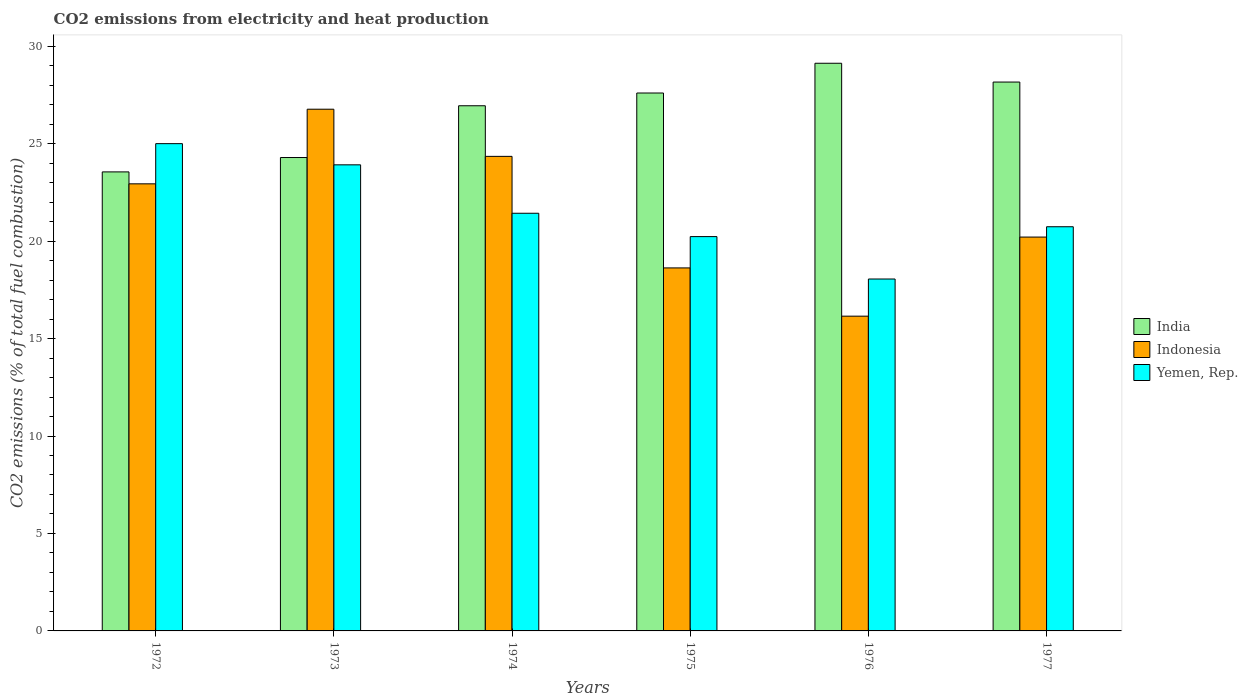How many groups of bars are there?
Your answer should be very brief. 6. Are the number of bars per tick equal to the number of legend labels?
Offer a very short reply. Yes. Are the number of bars on each tick of the X-axis equal?
Make the answer very short. Yes. How many bars are there on the 1st tick from the left?
Make the answer very short. 3. What is the label of the 4th group of bars from the left?
Ensure brevity in your answer.  1975. What is the amount of CO2 emitted in Yemen, Rep. in 1977?
Keep it short and to the point. 20.74. Across all years, what is the maximum amount of CO2 emitted in India?
Offer a very short reply. 29.12. Across all years, what is the minimum amount of CO2 emitted in Yemen, Rep.?
Give a very brief answer. 18.06. In which year was the amount of CO2 emitted in Indonesia maximum?
Make the answer very short. 1973. In which year was the amount of CO2 emitted in Yemen, Rep. minimum?
Make the answer very short. 1976. What is the total amount of CO2 emitted in India in the graph?
Provide a succinct answer. 159.67. What is the difference between the amount of CO2 emitted in Indonesia in 1976 and that in 1977?
Offer a very short reply. -4.06. What is the difference between the amount of CO2 emitted in Yemen, Rep. in 1975 and the amount of CO2 emitted in Indonesia in 1977?
Your response must be concise. 0.02. What is the average amount of CO2 emitted in Indonesia per year?
Provide a short and direct response. 21.51. In the year 1975, what is the difference between the amount of CO2 emitted in Yemen, Rep. and amount of CO2 emitted in India?
Offer a terse response. -7.37. What is the ratio of the amount of CO2 emitted in Yemen, Rep. in 1973 to that in 1977?
Offer a very short reply. 1.15. Is the amount of CO2 emitted in Yemen, Rep. in 1973 less than that in 1976?
Keep it short and to the point. No. Is the difference between the amount of CO2 emitted in Yemen, Rep. in 1975 and 1977 greater than the difference between the amount of CO2 emitted in India in 1975 and 1977?
Ensure brevity in your answer.  Yes. What is the difference between the highest and the second highest amount of CO2 emitted in Indonesia?
Offer a very short reply. 2.42. What is the difference between the highest and the lowest amount of CO2 emitted in Indonesia?
Give a very brief answer. 10.62. In how many years, is the amount of CO2 emitted in Indonesia greater than the average amount of CO2 emitted in Indonesia taken over all years?
Your answer should be very brief. 3. Is the sum of the amount of CO2 emitted in India in 1972 and 1976 greater than the maximum amount of CO2 emitted in Indonesia across all years?
Make the answer very short. Yes. What does the 3rd bar from the left in 1976 represents?
Your response must be concise. Yemen, Rep. How many years are there in the graph?
Offer a terse response. 6. What is the difference between two consecutive major ticks on the Y-axis?
Your answer should be compact. 5. Are the values on the major ticks of Y-axis written in scientific E-notation?
Provide a short and direct response. No. Does the graph contain any zero values?
Provide a succinct answer. No. Does the graph contain grids?
Provide a succinct answer. No. How are the legend labels stacked?
Offer a very short reply. Vertical. What is the title of the graph?
Give a very brief answer. CO2 emissions from electricity and heat production. What is the label or title of the Y-axis?
Provide a short and direct response. CO2 emissions (% of total fuel combustion). What is the CO2 emissions (% of total fuel combustion) of India in 1972?
Provide a short and direct response. 23.55. What is the CO2 emissions (% of total fuel combustion) in Indonesia in 1972?
Keep it short and to the point. 22.94. What is the CO2 emissions (% of total fuel combustion) in Yemen, Rep. in 1972?
Ensure brevity in your answer.  25. What is the CO2 emissions (% of total fuel combustion) in India in 1973?
Ensure brevity in your answer.  24.29. What is the CO2 emissions (% of total fuel combustion) of Indonesia in 1973?
Your answer should be very brief. 26.77. What is the CO2 emissions (% of total fuel combustion) in Yemen, Rep. in 1973?
Give a very brief answer. 23.91. What is the CO2 emissions (% of total fuel combustion) in India in 1974?
Offer a very short reply. 26.94. What is the CO2 emissions (% of total fuel combustion) of Indonesia in 1974?
Offer a very short reply. 24.35. What is the CO2 emissions (% of total fuel combustion) in Yemen, Rep. in 1974?
Offer a very short reply. 21.43. What is the CO2 emissions (% of total fuel combustion) in India in 1975?
Make the answer very short. 27.6. What is the CO2 emissions (% of total fuel combustion) in Indonesia in 1975?
Provide a succinct answer. 18.62. What is the CO2 emissions (% of total fuel combustion) in Yemen, Rep. in 1975?
Keep it short and to the point. 20.23. What is the CO2 emissions (% of total fuel combustion) of India in 1976?
Ensure brevity in your answer.  29.12. What is the CO2 emissions (% of total fuel combustion) of Indonesia in 1976?
Give a very brief answer. 16.15. What is the CO2 emissions (% of total fuel combustion) of Yemen, Rep. in 1976?
Your answer should be compact. 18.06. What is the CO2 emissions (% of total fuel combustion) of India in 1977?
Your answer should be very brief. 28.16. What is the CO2 emissions (% of total fuel combustion) in Indonesia in 1977?
Give a very brief answer. 20.21. What is the CO2 emissions (% of total fuel combustion) in Yemen, Rep. in 1977?
Your response must be concise. 20.74. Across all years, what is the maximum CO2 emissions (% of total fuel combustion) of India?
Offer a very short reply. 29.12. Across all years, what is the maximum CO2 emissions (% of total fuel combustion) of Indonesia?
Provide a short and direct response. 26.77. Across all years, what is the minimum CO2 emissions (% of total fuel combustion) in India?
Offer a very short reply. 23.55. Across all years, what is the minimum CO2 emissions (% of total fuel combustion) in Indonesia?
Provide a short and direct response. 16.15. Across all years, what is the minimum CO2 emissions (% of total fuel combustion) of Yemen, Rep.?
Offer a terse response. 18.06. What is the total CO2 emissions (% of total fuel combustion) in India in the graph?
Your response must be concise. 159.67. What is the total CO2 emissions (% of total fuel combustion) in Indonesia in the graph?
Ensure brevity in your answer.  129.03. What is the total CO2 emissions (% of total fuel combustion) of Yemen, Rep. in the graph?
Provide a short and direct response. 129.37. What is the difference between the CO2 emissions (% of total fuel combustion) of India in 1972 and that in 1973?
Your answer should be very brief. -0.74. What is the difference between the CO2 emissions (% of total fuel combustion) of Indonesia in 1972 and that in 1973?
Ensure brevity in your answer.  -3.83. What is the difference between the CO2 emissions (% of total fuel combustion) of Yemen, Rep. in 1972 and that in 1973?
Your answer should be compact. 1.09. What is the difference between the CO2 emissions (% of total fuel combustion) in India in 1972 and that in 1974?
Your answer should be very brief. -3.39. What is the difference between the CO2 emissions (% of total fuel combustion) of Indonesia in 1972 and that in 1974?
Ensure brevity in your answer.  -1.41. What is the difference between the CO2 emissions (% of total fuel combustion) of Yemen, Rep. in 1972 and that in 1974?
Keep it short and to the point. 3.57. What is the difference between the CO2 emissions (% of total fuel combustion) in India in 1972 and that in 1975?
Give a very brief answer. -4.05. What is the difference between the CO2 emissions (% of total fuel combustion) of Indonesia in 1972 and that in 1975?
Give a very brief answer. 4.31. What is the difference between the CO2 emissions (% of total fuel combustion) in Yemen, Rep. in 1972 and that in 1975?
Keep it short and to the point. 4.77. What is the difference between the CO2 emissions (% of total fuel combustion) in India in 1972 and that in 1976?
Offer a terse response. -5.57. What is the difference between the CO2 emissions (% of total fuel combustion) of Indonesia in 1972 and that in 1976?
Make the answer very short. 6.79. What is the difference between the CO2 emissions (% of total fuel combustion) in Yemen, Rep. in 1972 and that in 1976?
Give a very brief answer. 6.94. What is the difference between the CO2 emissions (% of total fuel combustion) in India in 1972 and that in 1977?
Provide a short and direct response. -4.61. What is the difference between the CO2 emissions (% of total fuel combustion) of Indonesia in 1972 and that in 1977?
Your answer should be compact. 2.73. What is the difference between the CO2 emissions (% of total fuel combustion) of Yemen, Rep. in 1972 and that in 1977?
Ensure brevity in your answer.  4.26. What is the difference between the CO2 emissions (% of total fuel combustion) of India in 1973 and that in 1974?
Offer a very short reply. -2.66. What is the difference between the CO2 emissions (% of total fuel combustion) in Indonesia in 1973 and that in 1974?
Give a very brief answer. 2.42. What is the difference between the CO2 emissions (% of total fuel combustion) of Yemen, Rep. in 1973 and that in 1974?
Your answer should be compact. 2.48. What is the difference between the CO2 emissions (% of total fuel combustion) in India in 1973 and that in 1975?
Ensure brevity in your answer.  -3.31. What is the difference between the CO2 emissions (% of total fuel combustion) of Indonesia in 1973 and that in 1975?
Provide a short and direct response. 8.14. What is the difference between the CO2 emissions (% of total fuel combustion) in Yemen, Rep. in 1973 and that in 1975?
Keep it short and to the point. 3.68. What is the difference between the CO2 emissions (% of total fuel combustion) of India in 1973 and that in 1976?
Give a very brief answer. -4.84. What is the difference between the CO2 emissions (% of total fuel combustion) of Indonesia in 1973 and that in 1976?
Make the answer very short. 10.62. What is the difference between the CO2 emissions (% of total fuel combustion) in Yemen, Rep. in 1973 and that in 1976?
Your answer should be compact. 5.86. What is the difference between the CO2 emissions (% of total fuel combustion) in India in 1973 and that in 1977?
Offer a very short reply. -3.87. What is the difference between the CO2 emissions (% of total fuel combustion) in Indonesia in 1973 and that in 1977?
Make the answer very short. 6.56. What is the difference between the CO2 emissions (% of total fuel combustion) of Yemen, Rep. in 1973 and that in 1977?
Provide a succinct answer. 3.18. What is the difference between the CO2 emissions (% of total fuel combustion) of India in 1974 and that in 1975?
Keep it short and to the point. -0.65. What is the difference between the CO2 emissions (% of total fuel combustion) in Indonesia in 1974 and that in 1975?
Your answer should be compact. 5.72. What is the difference between the CO2 emissions (% of total fuel combustion) in Yemen, Rep. in 1974 and that in 1975?
Your answer should be compact. 1.2. What is the difference between the CO2 emissions (% of total fuel combustion) in India in 1974 and that in 1976?
Provide a succinct answer. -2.18. What is the difference between the CO2 emissions (% of total fuel combustion) in Indonesia in 1974 and that in 1976?
Provide a succinct answer. 8.2. What is the difference between the CO2 emissions (% of total fuel combustion) in Yemen, Rep. in 1974 and that in 1976?
Offer a terse response. 3.37. What is the difference between the CO2 emissions (% of total fuel combustion) in India in 1974 and that in 1977?
Your answer should be very brief. -1.22. What is the difference between the CO2 emissions (% of total fuel combustion) in Indonesia in 1974 and that in 1977?
Make the answer very short. 4.14. What is the difference between the CO2 emissions (% of total fuel combustion) of Yemen, Rep. in 1974 and that in 1977?
Provide a succinct answer. 0.69. What is the difference between the CO2 emissions (% of total fuel combustion) in India in 1975 and that in 1976?
Offer a terse response. -1.53. What is the difference between the CO2 emissions (% of total fuel combustion) of Indonesia in 1975 and that in 1976?
Provide a short and direct response. 2.48. What is the difference between the CO2 emissions (% of total fuel combustion) in Yemen, Rep. in 1975 and that in 1976?
Keep it short and to the point. 2.18. What is the difference between the CO2 emissions (% of total fuel combustion) of India in 1975 and that in 1977?
Ensure brevity in your answer.  -0.56. What is the difference between the CO2 emissions (% of total fuel combustion) of Indonesia in 1975 and that in 1977?
Offer a very short reply. -1.58. What is the difference between the CO2 emissions (% of total fuel combustion) of Yemen, Rep. in 1975 and that in 1977?
Provide a succinct answer. -0.51. What is the difference between the CO2 emissions (% of total fuel combustion) of India in 1976 and that in 1977?
Your answer should be compact. 0.96. What is the difference between the CO2 emissions (% of total fuel combustion) in Indonesia in 1976 and that in 1977?
Your answer should be compact. -4.06. What is the difference between the CO2 emissions (% of total fuel combustion) of Yemen, Rep. in 1976 and that in 1977?
Make the answer very short. -2.68. What is the difference between the CO2 emissions (% of total fuel combustion) of India in 1972 and the CO2 emissions (% of total fuel combustion) of Indonesia in 1973?
Provide a succinct answer. -3.22. What is the difference between the CO2 emissions (% of total fuel combustion) of India in 1972 and the CO2 emissions (% of total fuel combustion) of Yemen, Rep. in 1973?
Give a very brief answer. -0.36. What is the difference between the CO2 emissions (% of total fuel combustion) in Indonesia in 1972 and the CO2 emissions (% of total fuel combustion) in Yemen, Rep. in 1973?
Your answer should be compact. -0.97. What is the difference between the CO2 emissions (% of total fuel combustion) of India in 1972 and the CO2 emissions (% of total fuel combustion) of Indonesia in 1974?
Your answer should be very brief. -0.8. What is the difference between the CO2 emissions (% of total fuel combustion) of India in 1972 and the CO2 emissions (% of total fuel combustion) of Yemen, Rep. in 1974?
Your answer should be compact. 2.12. What is the difference between the CO2 emissions (% of total fuel combustion) of Indonesia in 1972 and the CO2 emissions (% of total fuel combustion) of Yemen, Rep. in 1974?
Give a very brief answer. 1.51. What is the difference between the CO2 emissions (% of total fuel combustion) of India in 1972 and the CO2 emissions (% of total fuel combustion) of Indonesia in 1975?
Give a very brief answer. 4.93. What is the difference between the CO2 emissions (% of total fuel combustion) of India in 1972 and the CO2 emissions (% of total fuel combustion) of Yemen, Rep. in 1975?
Offer a terse response. 3.32. What is the difference between the CO2 emissions (% of total fuel combustion) in Indonesia in 1972 and the CO2 emissions (% of total fuel combustion) in Yemen, Rep. in 1975?
Your answer should be very brief. 2.71. What is the difference between the CO2 emissions (% of total fuel combustion) of India in 1972 and the CO2 emissions (% of total fuel combustion) of Indonesia in 1976?
Your answer should be compact. 7.4. What is the difference between the CO2 emissions (% of total fuel combustion) of India in 1972 and the CO2 emissions (% of total fuel combustion) of Yemen, Rep. in 1976?
Your response must be concise. 5.5. What is the difference between the CO2 emissions (% of total fuel combustion) of Indonesia in 1972 and the CO2 emissions (% of total fuel combustion) of Yemen, Rep. in 1976?
Ensure brevity in your answer.  4.88. What is the difference between the CO2 emissions (% of total fuel combustion) in India in 1972 and the CO2 emissions (% of total fuel combustion) in Indonesia in 1977?
Your answer should be compact. 3.34. What is the difference between the CO2 emissions (% of total fuel combustion) of India in 1972 and the CO2 emissions (% of total fuel combustion) of Yemen, Rep. in 1977?
Ensure brevity in your answer.  2.81. What is the difference between the CO2 emissions (% of total fuel combustion) in Indonesia in 1972 and the CO2 emissions (% of total fuel combustion) in Yemen, Rep. in 1977?
Make the answer very short. 2.2. What is the difference between the CO2 emissions (% of total fuel combustion) of India in 1973 and the CO2 emissions (% of total fuel combustion) of Indonesia in 1974?
Your response must be concise. -0.06. What is the difference between the CO2 emissions (% of total fuel combustion) in India in 1973 and the CO2 emissions (% of total fuel combustion) in Yemen, Rep. in 1974?
Your answer should be compact. 2.86. What is the difference between the CO2 emissions (% of total fuel combustion) of Indonesia in 1973 and the CO2 emissions (% of total fuel combustion) of Yemen, Rep. in 1974?
Your answer should be compact. 5.34. What is the difference between the CO2 emissions (% of total fuel combustion) in India in 1973 and the CO2 emissions (% of total fuel combustion) in Indonesia in 1975?
Give a very brief answer. 5.66. What is the difference between the CO2 emissions (% of total fuel combustion) of India in 1973 and the CO2 emissions (% of total fuel combustion) of Yemen, Rep. in 1975?
Offer a very short reply. 4.06. What is the difference between the CO2 emissions (% of total fuel combustion) of Indonesia in 1973 and the CO2 emissions (% of total fuel combustion) of Yemen, Rep. in 1975?
Offer a very short reply. 6.54. What is the difference between the CO2 emissions (% of total fuel combustion) of India in 1973 and the CO2 emissions (% of total fuel combustion) of Indonesia in 1976?
Ensure brevity in your answer.  8.14. What is the difference between the CO2 emissions (% of total fuel combustion) of India in 1973 and the CO2 emissions (% of total fuel combustion) of Yemen, Rep. in 1976?
Ensure brevity in your answer.  6.23. What is the difference between the CO2 emissions (% of total fuel combustion) in Indonesia in 1973 and the CO2 emissions (% of total fuel combustion) in Yemen, Rep. in 1976?
Your answer should be compact. 8.71. What is the difference between the CO2 emissions (% of total fuel combustion) in India in 1973 and the CO2 emissions (% of total fuel combustion) in Indonesia in 1977?
Your answer should be very brief. 4.08. What is the difference between the CO2 emissions (% of total fuel combustion) in India in 1973 and the CO2 emissions (% of total fuel combustion) in Yemen, Rep. in 1977?
Offer a very short reply. 3.55. What is the difference between the CO2 emissions (% of total fuel combustion) of Indonesia in 1973 and the CO2 emissions (% of total fuel combustion) of Yemen, Rep. in 1977?
Keep it short and to the point. 6.03. What is the difference between the CO2 emissions (% of total fuel combustion) of India in 1974 and the CO2 emissions (% of total fuel combustion) of Indonesia in 1975?
Offer a very short reply. 8.32. What is the difference between the CO2 emissions (% of total fuel combustion) of India in 1974 and the CO2 emissions (% of total fuel combustion) of Yemen, Rep. in 1975?
Offer a very short reply. 6.71. What is the difference between the CO2 emissions (% of total fuel combustion) of Indonesia in 1974 and the CO2 emissions (% of total fuel combustion) of Yemen, Rep. in 1975?
Ensure brevity in your answer.  4.12. What is the difference between the CO2 emissions (% of total fuel combustion) in India in 1974 and the CO2 emissions (% of total fuel combustion) in Indonesia in 1976?
Provide a succinct answer. 10.8. What is the difference between the CO2 emissions (% of total fuel combustion) in India in 1974 and the CO2 emissions (% of total fuel combustion) in Yemen, Rep. in 1976?
Keep it short and to the point. 8.89. What is the difference between the CO2 emissions (% of total fuel combustion) in Indonesia in 1974 and the CO2 emissions (% of total fuel combustion) in Yemen, Rep. in 1976?
Give a very brief answer. 6.29. What is the difference between the CO2 emissions (% of total fuel combustion) in India in 1974 and the CO2 emissions (% of total fuel combustion) in Indonesia in 1977?
Give a very brief answer. 6.74. What is the difference between the CO2 emissions (% of total fuel combustion) in India in 1974 and the CO2 emissions (% of total fuel combustion) in Yemen, Rep. in 1977?
Your answer should be compact. 6.21. What is the difference between the CO2 emissions (% of total fuel combustion) in Indonesia in 1974 and the CO2 emissions (% of total fuel combustion) in Yemen, Rep. in 1977?
Offer a terse response. 3.61. What is the difference between the CO2 emissions (% of total fuel combustion) of India in 1975 and the CO2 emissions (% of total fuel combustion) of Indonesia in 1976?
Offer a terse response. 11.45. What is the difference between the CO2 emissions (% of total fuel combustion) in India in 1975 and the CO2 emissions (% of total fuel combustion) in Yemen, Rep. in 1976?
Offer a very short reply. 9.54. What is the difference between the CO2 emissions (% of total fuel combustion) of Indonesia in 1975 and the CO2 emissions (% of total fuel combustion) of Yemen, Rep. in 1976?
Your answer should be compact. 0.57. What is the difference between the CO2 emissions (% of total fuel combustion) of India in 1975 and the CO2 emissions (% of total fuel combustion) of Indonesia in 1977?
Your answer should be compact. 7.39. What is the difference between the CO2 emissions (% of total fuel combustion) in India in 1975 and the CO2 emissions (% of total fuel combustion) in Yemen, Rep. in 1977?
Your response must be concise. 6.86. What is the difference between the CO2 emissions (% of total fuel combustion) in Indonesia in 1975 and the CO2 emissions (% of total fuel combustion) in Yemen, Rep. in 1977?
Keep it short and to the point. -2.11. What is the difference between the CO2 emissions (% of total fuel combustion) in India in 1976 and the CO2 emissions (% of total fuel combustion) in Indonesia in 1977?
Offer a very short reply. 8.92. What is the difference between the CO2 emissions (% of total fuel combustion) in India in 1976 and the CO2 emissions (% of total fuel combustion) in Yemen, Rep. in 1977?
Your response must be concise. 8.39. What is the difference between the CO2 emissions (% of total fuel combustion) of Indonesia in 1976 and the CO2 emissions (% of total fuel combustion) of Yemen, Rep. in 1977?
Your response must be concise. -4.59. What is the average CO2 emissions (% of total fuel combustion) of India per year?
Give a very brief answer. 26.61. What is the average CO2 emissions (% of total fuel combustion) in Indonesia per year?
Offer a very short reply. 21.51. What is the average CO2 emissions (% of total fuel combustion) in Yemen, Rep. per year?
Offer a very short reply. 21.56. In the year 1972, what is the difference between the CO2 emissions (% of total fuel combustion) of India and CO2 emissions (% of total fuel combustion) of Indonesia?
Your answer should be very brief. 0.61. In the year 1972, what is the difference between the CO2 emissions (% of total fuel combustion) in India and CO2 emissions (% of total fuel combustion) in Yemen, Rep.?
Make the answer very short. -1.45. In the year 1972, what is the difference between the CO2 emissions (% of total fuel combustion) of Indonesia and CO2 emissions (% of total fuel combustion) of Yemen, Rep.?
Your answer should be compact. -2.06. In the year 1973, what is the difference between the CO2 emissions (% of total fuel combustion) of India and CO2 emissions (% of total fuel combustion) of Indonesia?
Keep it short and to the point. -2.48. In the year 1973, what is the difference between the CO2 emissions (% of total fuel combustion) of India and CO2 emissions (% of total fuel combustion) of Yemen, Rep.?
Provide a succinct answer. 0.38. In the year 1973, what is the difference between the CO2 emissions (% of total fuel combustion) of Indonesia and CO2 emissions (% of total fuel combustion) of Yemen, Rep.?
Offer a very short reply. 2.85. In the year 1974, what is the difference between the CO2 emissions (% of total fuel combustion) in India and CO2 emissions (% of total fuel combustion) in Indonesia?
Ensure brevity in your answer.  2.6. In the year 1974, what is the difference between the CO2 emissions (% of total fuel combustion) in India and CO2 emissions (% of total fuel combustion) in Yemen, Rep.?
Offer a terse response. 5.52. In the year 1974, what is the difference between the CO2 emissions (% of total fuel combustion) of Indonesia and CO2 emissions (% of total fuel combustion) of Yemen, Rep.?
Keep it short and to the point. 2.92. In the year 1975, what is the difference between the CO2 emissions (% of total fuel combustion) of India and CO2 emissions (% of total fuel combustion) of Indonesia?
Ensure brevity in your answer.  8.97. In the year 1975, what is the difference between the CO2 emissions (% of total fuel combustion) of India and CO2 emissions (% of total fuel combustion) of Yemen, Rep.?
Provide a short and direct response. 7.37. In the year 1975, what is the difference between the CO2 emissions (% of total fuel combustion) in Indonesia and CO2 emissions (% of total fuel combustion) in Yemen, Rep.?
Your answer should be very brief. -1.61. In the year 1976, what is the difference between the CO2 emissions (% of total fuel combustion) in India and CO2 emissions (% of total fuel combustion) in Indonesia?
Make the answer very short. 12.98. In the year 1976, what is the difference between the CO2 emissions (% of total fuel combustion) of India and CO2 emissions (% of total fuel combustion) of Yemen, Rep.?
Ensure brevity in your answer.  11.07. In the year 1976, what is the difference between the CO2 emissions (% of total fuel combustion) in Indonesia and CO2 emissions (% of total fuel combustion) in Yemen, Rep.?
Give a very brief answer. -1.91. In the year 1977, what is the difference between the CO2 emissions (% of total fuel combustion) in India and CO2 emissions (% of total fuel combustion) in Indonesia?
Your response must be concise. 7.95. In the year 1977, what is the difference between the CO2 emissions (% of total fuel combustion) in India and CO2 emissions (% of total fuel combustion) in Yemen, Rep.?
Provide a succinct answer. 7.42. In the year 1977, what is the difference between the CO2 emissions (% of total fuel combustion) in Indonesia and CO2 emissions (% of total fuel combustion) in Yemen, Rep.?
Offer a terse response. -0.53. What is the ratio of the CO2 emissions (% of total fuel combustion) in India in 1972 to that in 1973?
Offer a very short reply. 0.97. What is the ratio of the CO2 emissions (% of total fuel combustion) in Indonesia in 1972 to that in 1973?
Keep it short and to the point. 0.86. What is the ratio of the CO2 emissions (% of total fuel combustion) in Yemen, Rep. in 1972 to that in 1973?
Give a very brief answer. 1.05. What is the ratio of the CO2 emissions (% of total fuel combustion) of India in 1972 to that in 1974?
Keep it short and to the point. 0.87. What is the ratio of the CO2 emissions (% of total fuel combustion) in Indonesia in 1972 to that in 1974?
Provide a succinct answer. 0.94. What is the ratio of the CO2 emissions (% of total fuel combustion) of Yemen, Rep. in 1972 to that in 1974?
Provide a succinct answer. 1.17. What is the ratio of the CO2 emissions (% of total fuel combustion) of India in 1972 to that in 1975?
Keep it short and to the point. 0.85. What is the ratio of the CO2 emissions (% of total fuel combustion) of Indonesia in 1972 to that in 1975?
Ensure brevity in your answer.  1.23. What is the ratio of the CO2 emissions (% of total fuel combustion) in Yemen, Rep. in 1972 to that in 1975?
Your answer should be compact. 1.24. What is the ratio of the CO2 emissions (% of total fuel combustion) of India in 1972 to that in 1976?
Your answer should be very brief. 0.81. What is the ratio of the CO2 emissions (% of total fuel combustion) in Indonesia in 1972 to that in 1976?
Give a very brief answer. 1.42. What is the ratio of the CO2 emissions (% of total fuel combustion) in Yemen, Rep. in 1972 to that in 1976?
Your answer should be compact. 1.38. What is the ratio of the CO2 emissions (% of total fuel combustion) of India in 1972 to that in 1977?
Your answer should be compact. 0.84. What is the ratio of the CO2 emissions (% of total fuel combustion) in Indonesia in 1972 to that in 1977?
Ensure brevity in your answer.  1.14. What is the ratio of the CO2 emissions (% of total fuel combustion) of Yemen, Rep. in 1972 to that in 1977?
Ensure brevity in your answer.  1.21. What is the ratio of the CO2 emissions (% of total fuel combustion) in India in 1973 to that in 1974?
Offer a terse response. 0.9. What is the ratio of the CO2 emissions (% of total fuel combustion) in Indonesia in 1973 to that in 1974?
Offer a terse response. 1.1. What is the ratio of the CO2 emissions (% of total fuel combustion) of Yemen, Rep. in 1973 to that in 1974?
Your answer should be compact. 1.12. What is the ratio of the CO2 emissions (% of total fuel combustion) in India in 1973 to that in 1975?
Offer a very short reply. 0.88. What is the ratio of the CO2 emissions (% of total fuel combustion) of Indonesia in 1973 to that in 1975?
Ensure brevity in your answer.  1.44. What is the ratio of the CO2 emissions (% of total fuel combustion) of Yemen, Rep. in 1973 to that in 1975?
Offer a terse response. 1.18. What is the ratio of the CO2 emissions (% of total fuel combustion) in India in 1973 to that in 1976?
Provide a succinct answer. 0.83. What is the ratio of the CO2 emissions (% of total fuel combustion) in Indonesia in 1973 to that in 1976?
Offer a very short reply. 1.66. What is the ratio of the CO2 emissions (% of total fuel combustion) in Yemen, Rep. in 1973 to that in 1976?
Offer a terse response. 1.32. What is the ratio of the CO2 emissions (% of total fuel combustion) in India in 1973 to that in 1977?
Make the answer very short. 0.86. What is the ratio of the CO2 emissions (% of total fuel combustion) in Indonesia in 1973 to that in 1977?
Make the answer very short. 1.32. What is the ratio of the CO2 emissions (% of total fuel combustion) of Yemen, Rep. in 1973 to that in 1977?
Make the answer very short. 1.15. What is the ratio of the CO2 emissions (% of total fuel combustion) in India in 1974 to that in 1975?
Provide a succinct answer. 0.98. What is the ratio of the CO2 emissions (% of total fuel combustion) of Indonesia in 1974 to that in 1975?
Offer a very short reply. 1.31. What is the ratio of the CO2 emissions (% of total fuel combustion) of Yemen, Rep. in 1974 to that in 1975?
Make the answer very short. 1.06. What is the ratio of the CO2 emissions (% of total fuel combustion) of India in 1974 to that in 1976?
Offer a very short reply. 0.93. What is the ratio of the CO2 emissions (% of total fuel combustion) of Indonesia in 1974 to that in 1976?
Offer a terse response. 1.51. What is the ratio of the CO2 emissions (% of total fuel combustion) in Yemen, Rep. in 1974 to that in 1976?
Provide a succinct answer. 1.19. What is the ratio of the CO2 emissions (% of total fuel combustion) in India in 1974 to that in 1977?
Offer a very short reply. 0.96. What is the ratio of the CO2 emissions (% of total fuel combustion) of Indonesia in 1974 to that in 1977?
Offer a very short reply. 1.2. What is the ratio of the CO2 emissions (% of total fuel combustion) of Yemen, Rep. in 1974 to that in 1977?
Give a very brief answer. 1.03. What is the ratio of the CO2 emissions (% of total fuel combustion) of India in 1975 to that in 1976?
Ensure brevity in your answer.  0.95. What is the ratio of the CO2 emissions (% of total fuel combustion) in Indonesia in 1975 to that in 1976?
Ensure brevity in your answer.  1.15. What is the ratio of the CO2 emissions (% of total fuel combustion) in Yemen, Rep. in 1975 to that in 1976?
Provide a short and direct response. 1.12. What is the ratio of the CO2 emissions (% of total fuel combustion) of India in 1975 to that in 1977?
Ensure brevity in your answer.  0.98. What is the ratio of the CO2 emissions (% of total fuel combustion) in Indonesia in 1975 to that in 1977?
Offer a terse response. 0.92. What is the ratio of the CO2 emissions (% of total fuel combustion) of Yemen, Rep. in 1975 to that in 1977?
Offer a terse response. 0.98. What is the ratio of the CO2 emissions (% of total fuel combustion) of India in 1976 to that in 1977?
Your response must be concise. 1.03. What is the ratio of the CO2 emissions (% of total fuel combustion) of Indonesia in 1976 to that in 1977?
Your answer should be very brief. 0.8. What is the ratio of the CO2 emissions (% of total fuel combustion) in Yemen, Rep. in 1976 to that in 1977?
Your answer should be very brief. 0.87. What is the difference between the highest and the second highest CO2 emissions (% of total fuel combustion) in India?
Make the answer very short. 0.96. What is the difference between the highest and the second highest CO2 emissions (% of total fuel combustion) in Indonesia?
Provide a short and direct response. 2.42. What is the difference between the highest and the second highest CO2 emissions (% of total fuel combustion) in Yemen, Rep.?
Provide a succinct answer. 1.09. What is the difference between the highest and the lowest CO2 emissions (% of total fuel combustion) of India?
Provide a short and direct response. 5.57. What is the difference between the highest and the lowest CO2 emissions (% of total fuel combustion) in Indonesia?
Offer a very short reply. 10.62. What is the difference between the highest and the lowest CO2 emissions (% of total fuel combustion) in Yemen, Rep.?
Offer a very short reply. 6.94. 